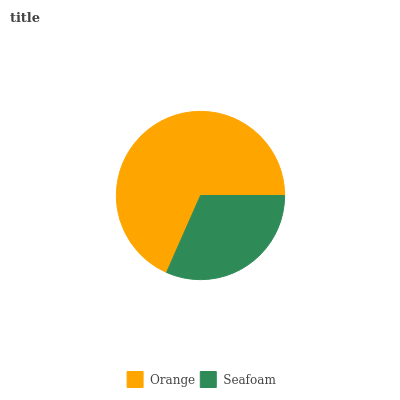Is Seafoam the minimum?
Answer yes or no. Yes. Is Orange the maximum?
Answer yes or no. Yes. Is Seafoam the maximum?
Answer yes or no. No. Is Orange greater than Seafoam?
Answer yes or no. Yes. Is Seafoam less than Orange?
Answer yes or no. Yes. Is Seafoam greater than Orange?
Answer yes or no. No. Is Orange less than Seafoam?
Answer yes or no. No. Is Orange the high median?
Answer yes or no. Yes. Is Seafoam the low median?
Answer yes or no. Yes. Is Seafoam the high median?
Answer yes or no. No. Is Orange the low median?
Answer yes or no. No. 